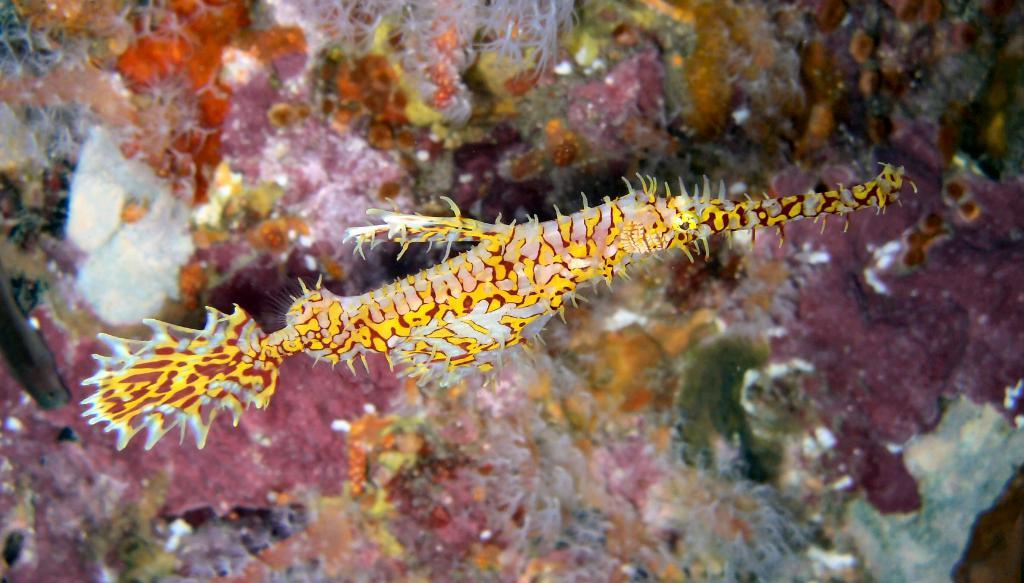What is the main subject of the image? There is a fish in the image. Can you describe the background of the image? There are objects in the background of the image. What type of sack can be seen in the image? There is no sack present in the image. Where is the lunchroom located in the image? There is no lunchroom depicted in the image. 